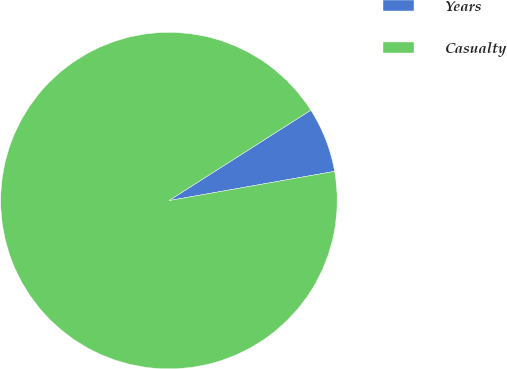Convert chart to OTSL. <chart><loc_0><loc_0><loc_500><loc_500><pie_chart><fcel>Years<fcel>Casualty<nl><fcel>6.25%<fcel>93.75%<nl></chart> 